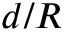<formula> <loc_0><loc_0><loc_500><loc_500>d / R</formula> 